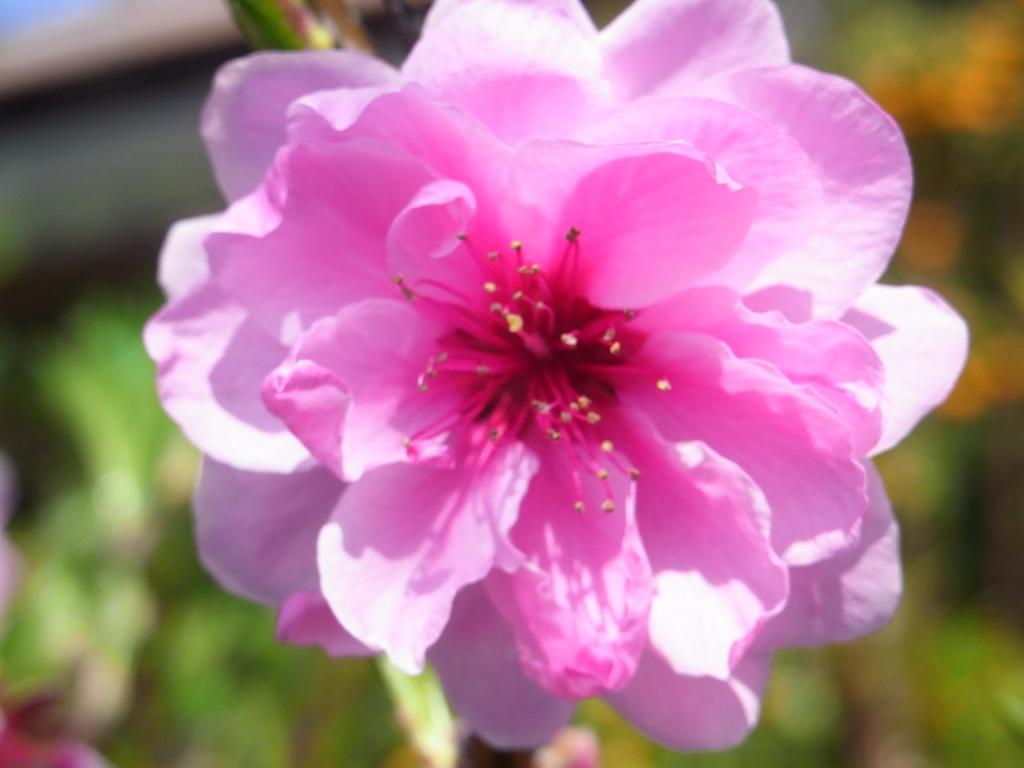What color is the flower in the image? The flower in the image is pink. What type of plant does the flower belong to? The flower belongs to a plant. Can you describe the background of the image? The background of the image is blurred. What did the person learn from the aftermath of the flower in the image? There is no person or learning involved in the image, as it only features a pink flower and a blurred background. 